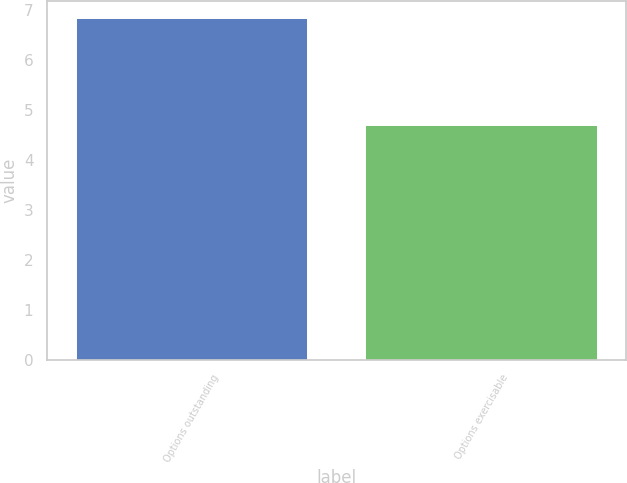<chart> <loc_0><loc_0><loc_500><loc_500><bar_chart><fcel>Options outstanding<fcel>Options exercisable<nl><fcel>6.85<fcel>4.71<nl></chart> 